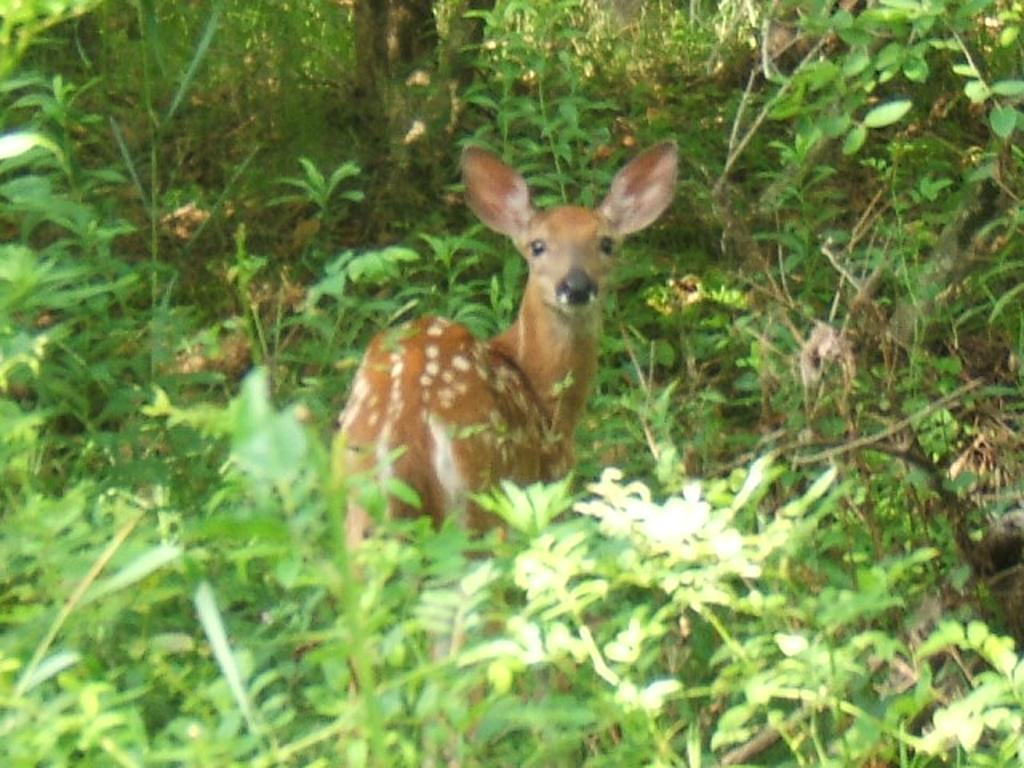What animal is present in the image? There is a deer in the image. Can you describe the coloring of the deer? The deer has brown and cream coloring. What can be seen in the background of the image? There are plants in the background of the image. What is the color of the plants in the image? The plants are green in color. What type of grip does the deer have on the building in the image? There is no building present in the image, and therefore no grip or interaction with a building can be observed. 